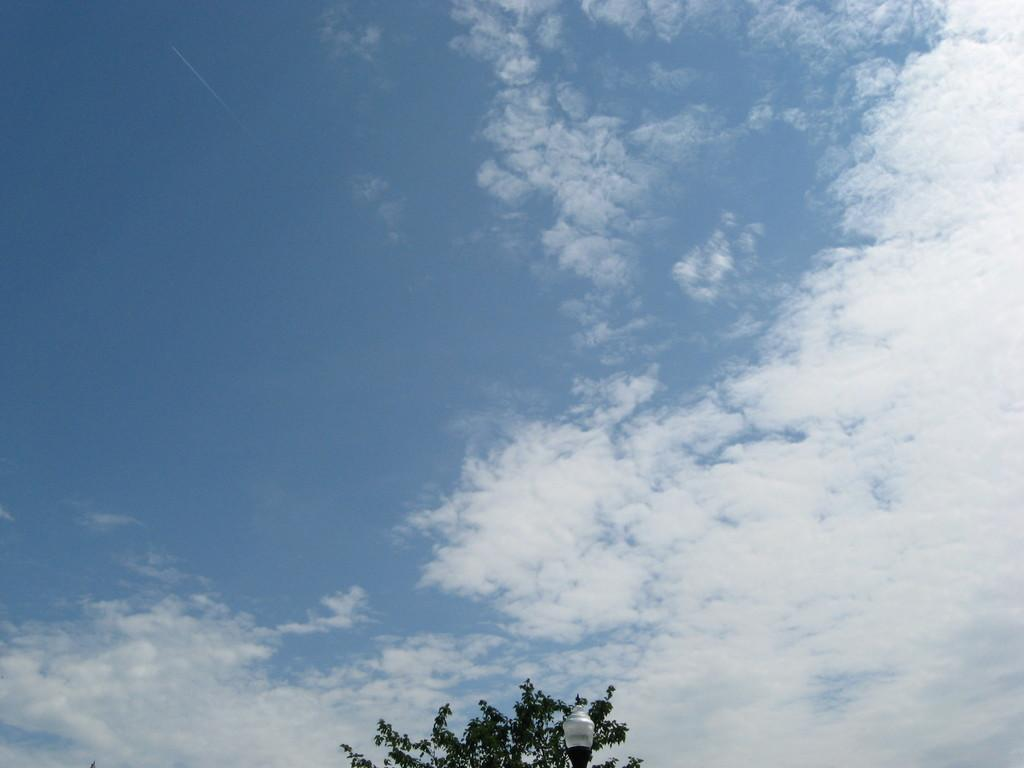What type of vegetation can be seen in the image? There are leaves in the image. What structure is present in the image? There is a light pole in the image. Where is the light pole located in the image? The light pole is on the bottom side of the image. What is visible in the background of the image? The sky is visible in the background of the image. What is the weather like in the image? The sky is clear in the image, suggesting good weather. What condition is the leg of the light pole in? There is no leg of the light pole mentioned in the image; the light pole is a single structure. What type of ray is visible in the image? There is no ray visible in the image; the image only features leaves, a light pole, and the sky. 